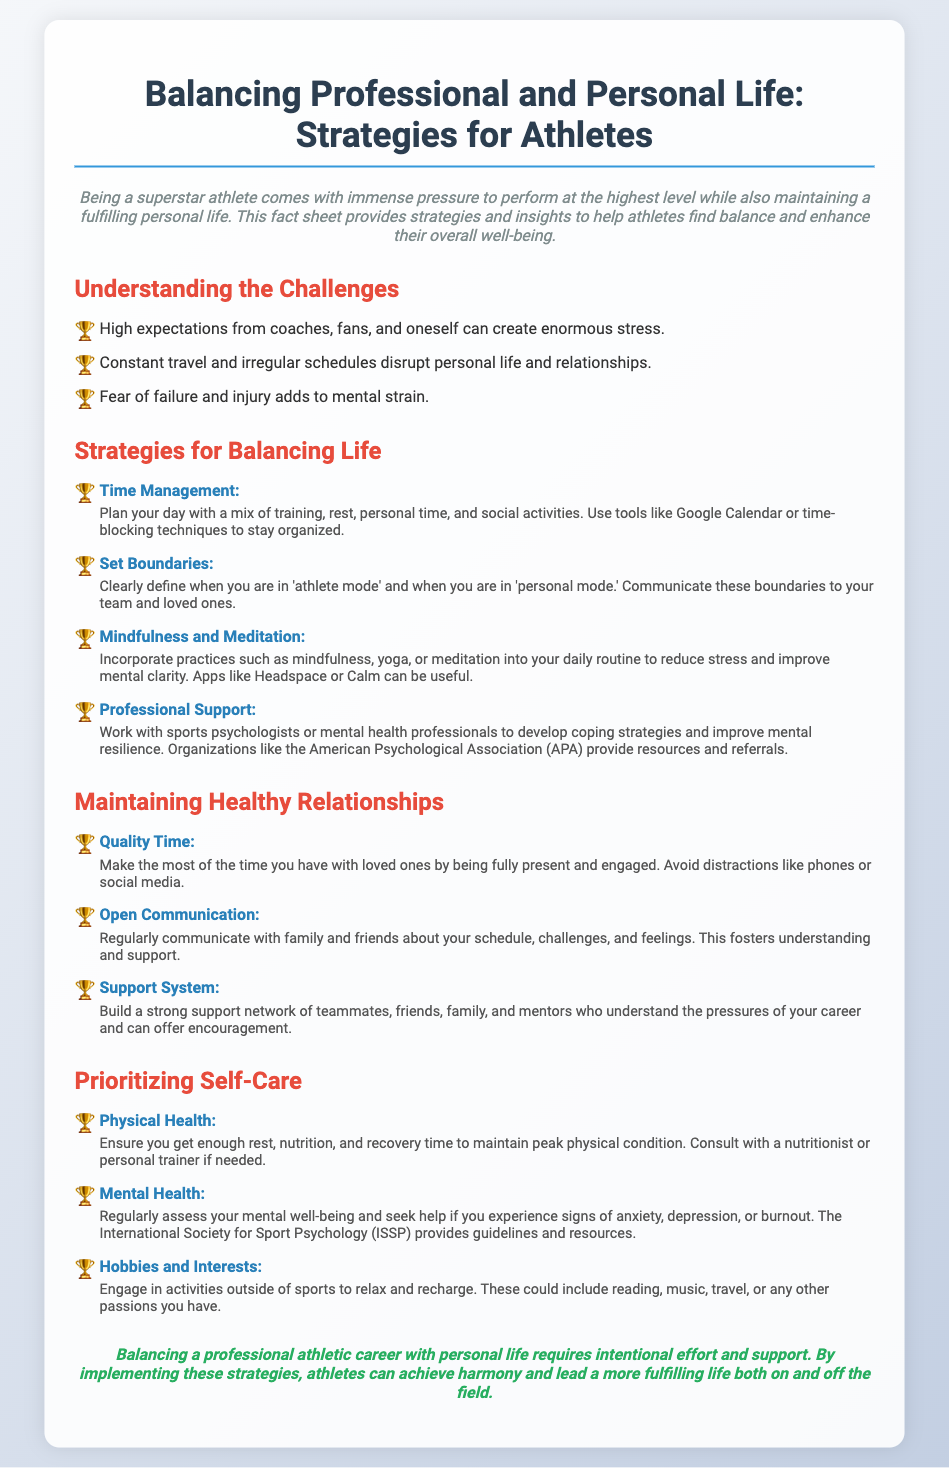what is the title of the document? The title of the document is presented at the top as the main heading.
Answer: Balancing Professional and Personal Life: Strategies for Athletes what color is used for subheadings? The color used for subheadings is specified in the style rules for h2 elements.
Answer: #e74c3c how many strategies for balancing life are listed? The number of strategies is determined by counting the list items under the section "Strategies for Balancing Life."
Answer: 4 what is the first strategy for balancing life? The first strategy is highlighted under the section discussing balancing life.
Answer: Time Management what should athletes prioritize for their physical health? The document mentions specific focuses regarding physical health in the self-care section.
Answer: Rest, nutrition, and recovery time which organization provides resources for mental resilience? The document refers to organizations that assist athletes in developing coping strategies.
Answer: American Psychological Association (APA) describe the type of support system athletes should build. The document characterizes the desired qualities of a support system for athletes.
Answer: Strong network of teammates, friends, family, and mentors what is a recommended app for mindfulness practices? The document suggests specific applications that can aid athletes in mindfulness.
Answer: Headspace what is emphasized for maintaining healthy relationships? The importance of a particular aspect relating to personal relationships is discussed in the document.
Answer: Open Communication 